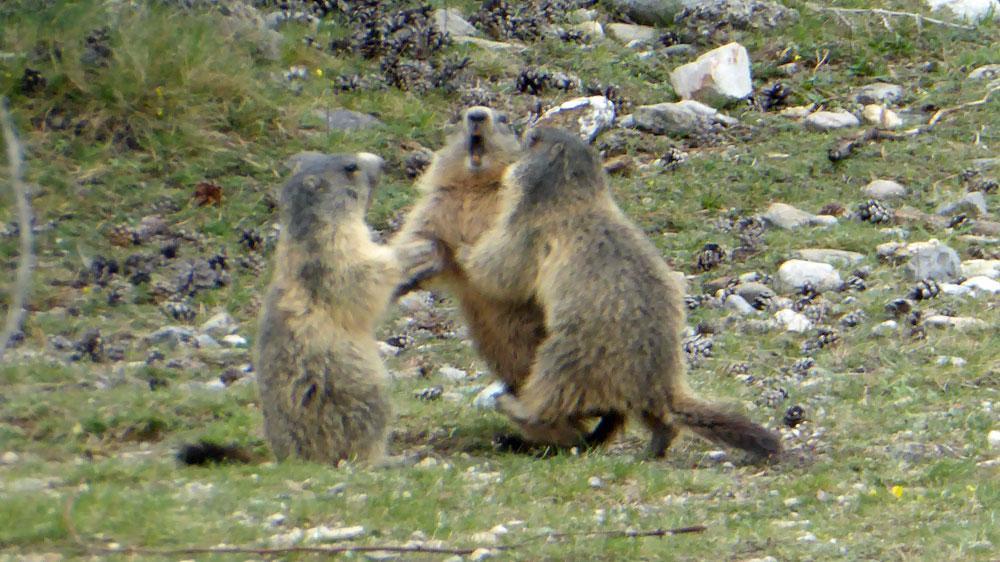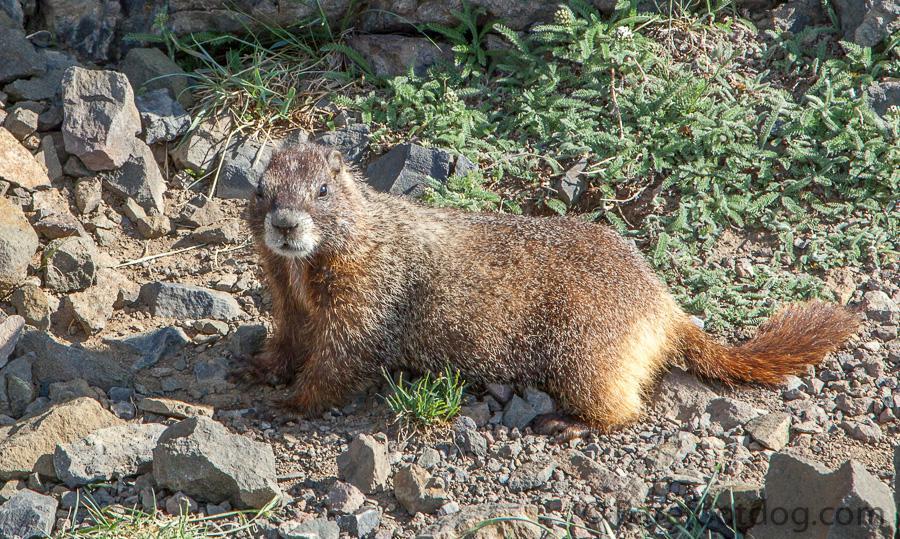The first image is the image on the left, the second image is the image on the right. Analyze the images presented: Is the assertion "Each image contains two animals, and at least two of the animals are touching." valid? Answer yes or no. No. The first image is the image on the left, the second image is the image on the right. Analyze the images presented: Is the assertion "At least one image includes at least two fully upright marmots with front paws touching another marmot." valid? Answer yes or no. Yes. 